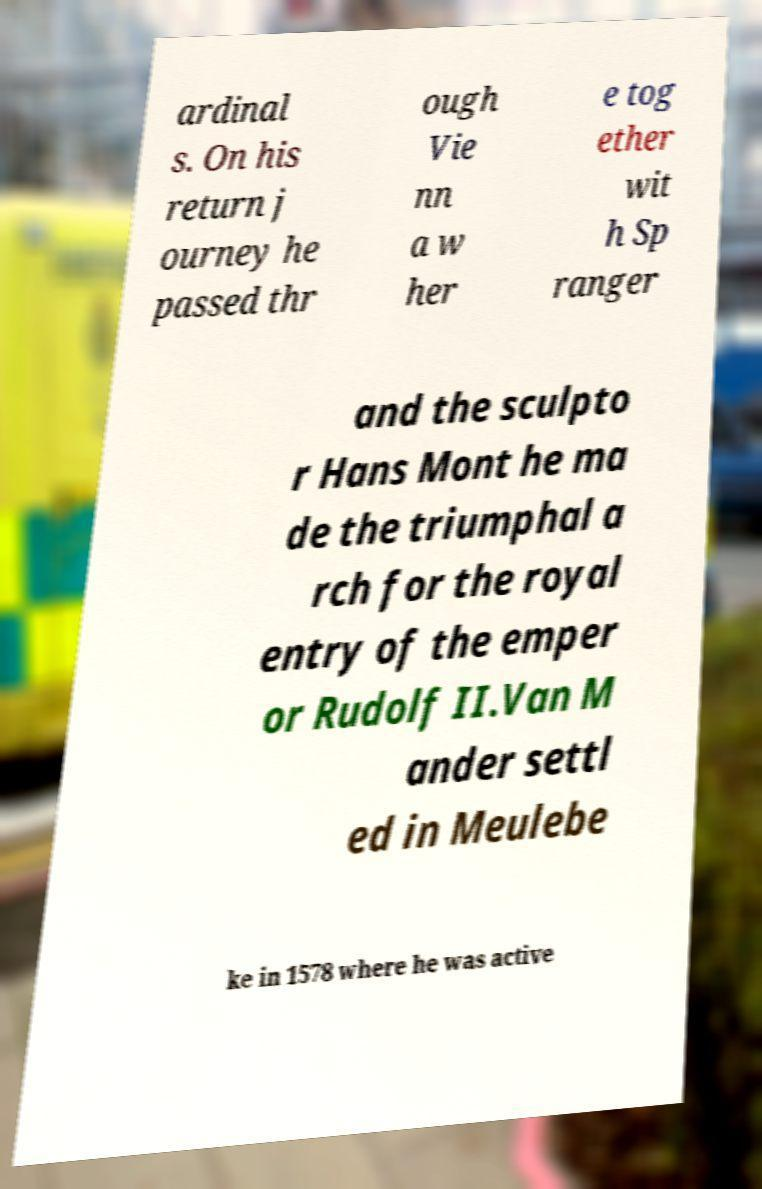Could you assist in decoding the text presented in this image and type it out clearly? ardinal s. On his return j ourney he passed thr ough Vie nn a w her e tog ether wit h Sp ranger and the sculpto r Hans Mont he ma de the triumphal a rch for the royal entry of the emper or Rudolf II.Van M ander settl ed in Meulebe ke in 1578 where he was active 